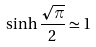<formula> <loc_0><loc_0><loc_500><loc_500>\sinh \frac { \sqrt { \pi } } { 2 } \simeq 1</formula> 